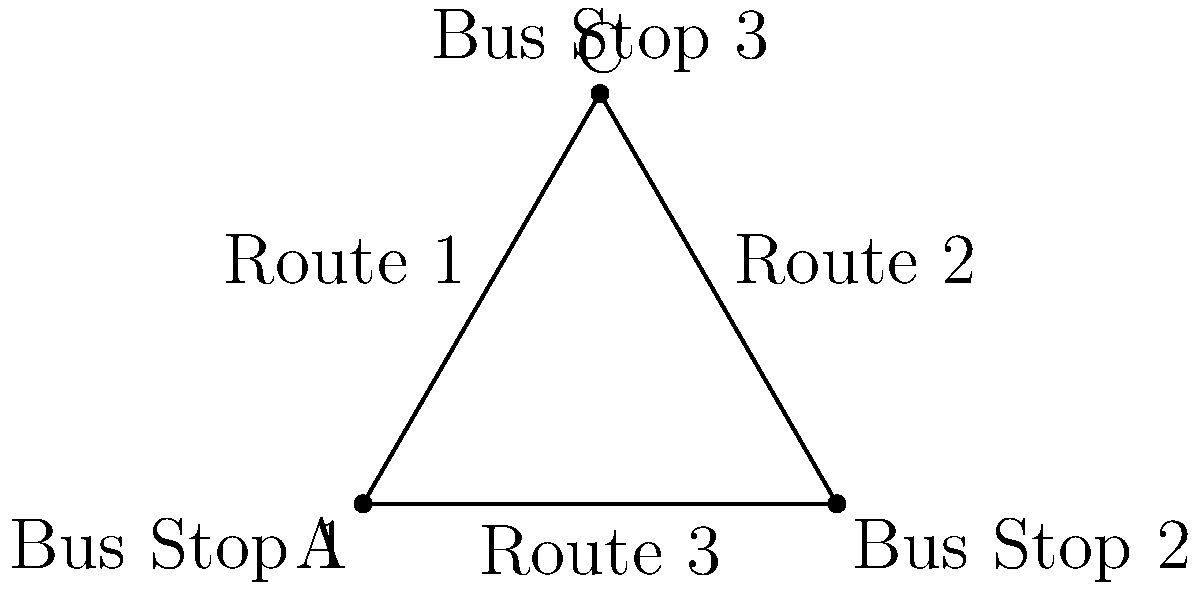A bus route map shows three stops forming an equilateral triangle. The bus travels between each pair of stops. How many symmetries does this route map have, including rotations and reflections? To determine the number of symmetries in this bus route map, we need to consider both rotations and reflections:

1. Rotational symmetries:
   - 0° (identity)
   - 120° clockwise
   - 240° clockwise (or 120° counterclockwise)

2. Reflection symmetries:
   - Reflection across the line from Bus Stop 1 to the midpoint of Route 2
   - Reflection across the line from Bus Stop 2 to the midpoint of Route 1
   - Reflection across the line from Bus Stop 3 to the midpoint of Route 3

The total number of symmetries is the sum of rotational and reflection symmetries:
3 (rotations) + 3 (reflections) = 6

This group of symmetries is known as the dihedral group D3, which is the symmetry group of an equilateral triangle.
Answer: 6 